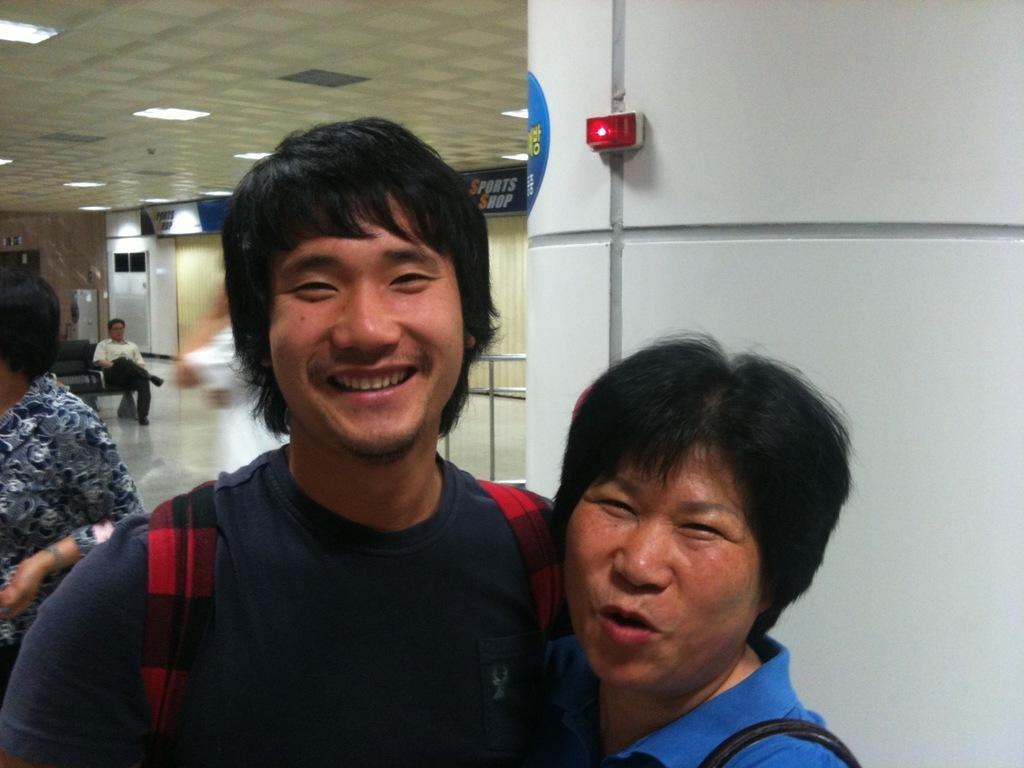In one or two sentences, can you explain what this image depicts? Here we can see two men carrying bags on their shoulders and smiling. On the left a man is standing. In the background we can see a man is sitting on the chair,doors,hoardings on the wall,lights on the ceiling and a red light on the right side wall. 